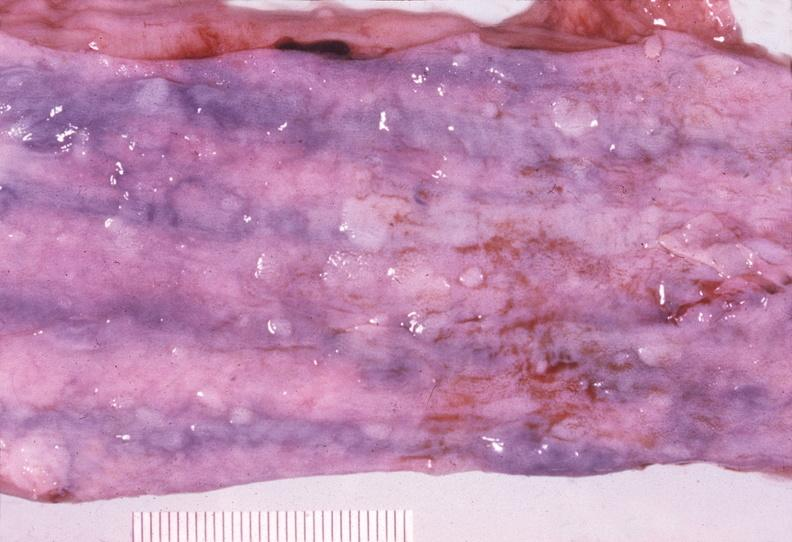does this image show esophagus, varices?
Answer the question using a single word or phrase. Yes 